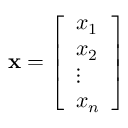Convert formula to latex. <formula><loc_0><loc_0><loc_500><loc_500>x = { \left [ \begin{array} { l } { x _ { 1 } } \\ { x _ { 2 } } \\ { \vdots } \\ { x _ { n } } \end{array} \right ] }</formula> 